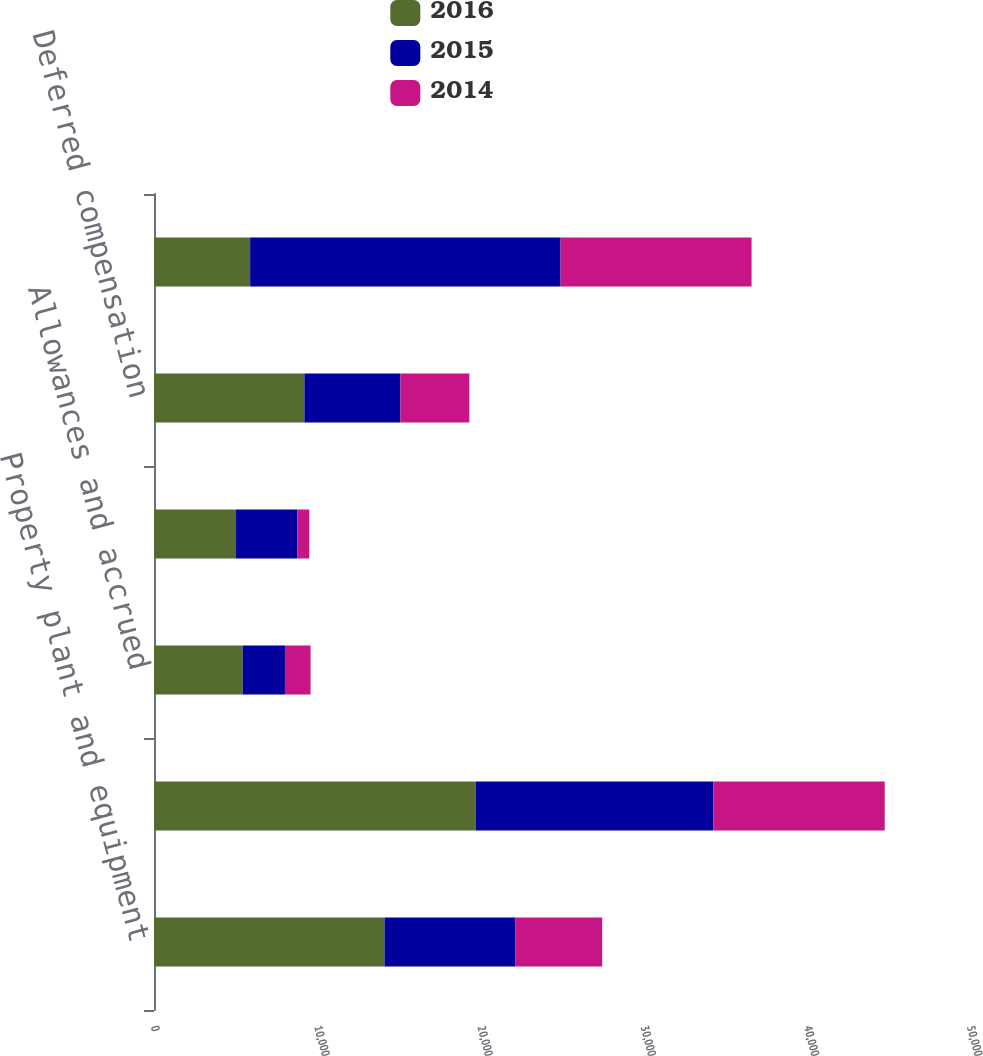Convert chart. <chart><loc_0><loc_0><loc_500><loc_500><stacked_bar_chart><ecel><fcel>Property plant and equipment<fcel>Inventory provisions<fcel>Allowances and accrued<fcel>Other tax credits<fcel>Deferred compensation<fcel>Net deferred tax assets<nl><fcel>2016<fcel>14122<fcel>19710<fcel>5434<fcel>5027<fcel>9215<fcel>5891<nl><fcel>2015<fcel>8031<fcel>14566<fcel>2590<fcel>3763<fcel>5891<fcel>19024<nl><fcel>2014<fcel>5310<fcel>10497<fcel>1570<fcel>726<fcel>4218<fcel>11701<nl></chart> 